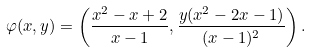Convert formula to latex. <formula><loc_0><loc_0><loc_500><loc_500>\varphi ( x , y ) = \left ( \frac { x ^ { 2 } - x + 2 } { x - 1 } , \frac { y ( x ^ { 2 } - 2 x - 1 ) } { ( x - 1 ) ^ { 2 } } \right ) .</formula> 